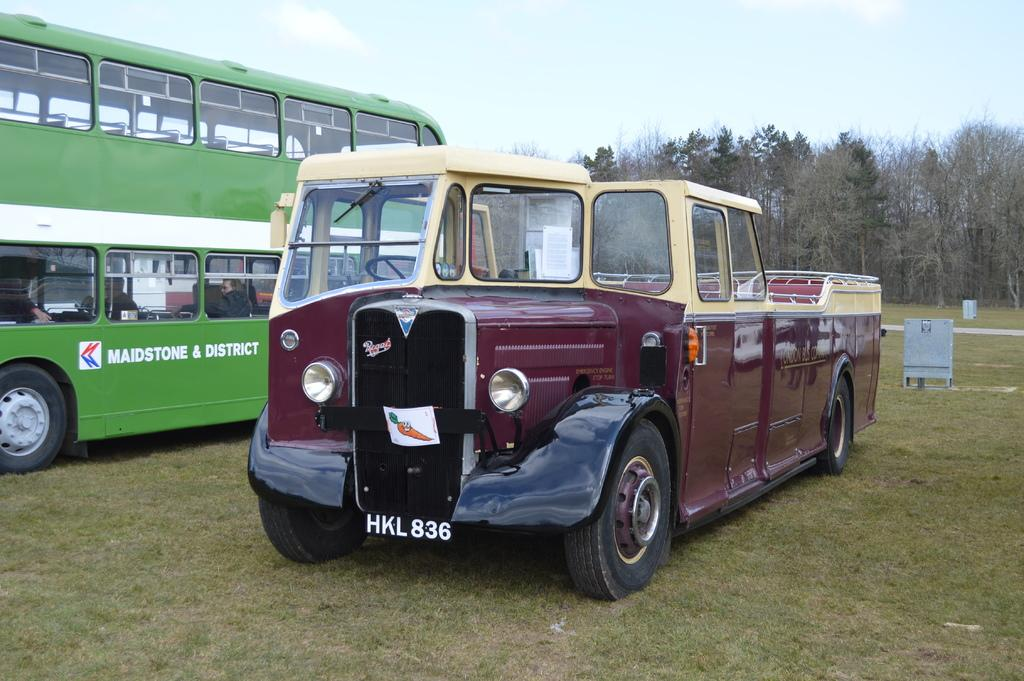What type of objects are on the ground in the image? There are motor vehicles on the ground in the image. What can be seen in the background of the image? Trees and the sky are visible in the background of the image. What is the condition of the sky in the image? Clouds are present in the sky in the image. What type of pie is being produced by the motor vehicles in the image? There is no pie being produced by the motor vehicles in the image. The motor vehicles are simply present on the ground, and there is no indication of any pie-related activity. 